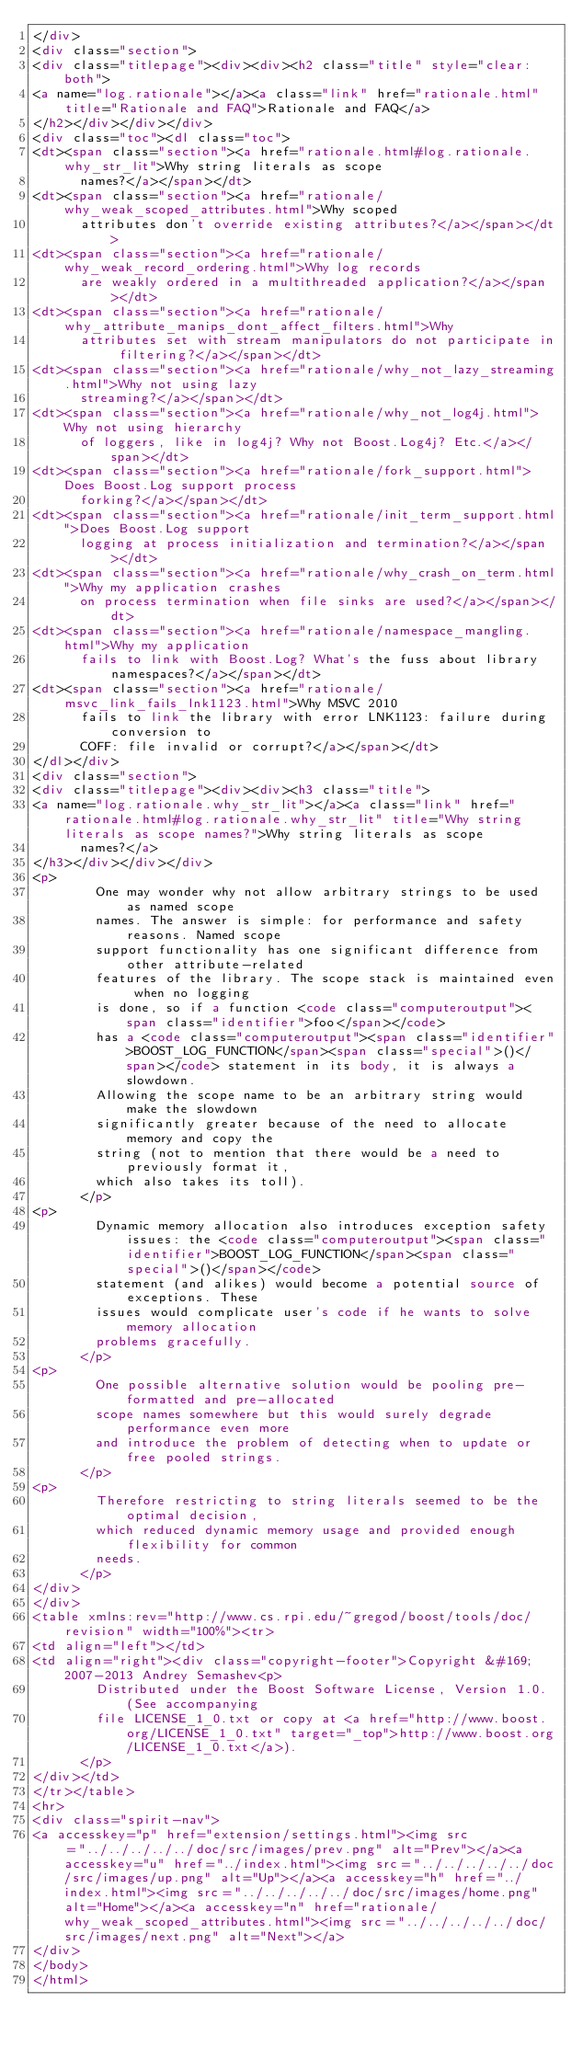Convert code to text. <code><loc_0><loc_0><loc_500><loc_500><_HTML_></div>
<div class="section">
<div class="titlepage"><div><div><h2 class="title" style="clear: both">
<a name="log.rationale"></a><a class="link" href="rationale.html" title="Rationale and FAQ">Rationale and FAQ</a>
</h2></div></div></div>
<div class="toc"><dl class="toc">
<dt><span class="section"><a href="rationale.html#log.rationale.why_str_lit">Why string literals as scope
      names?</a></span></dt>
<dt><span class="section"><a href="rationale/why_weak_scoped_attributes.html">Why scoped
      attributes don't override existing attributes?</a></span></dt>
<dt><span class="section"><a href="rationale/why_weak_record_ordering.html">Why log records
      are weakly ordered in a multithreaded application?</a></span></dt>
<dt><span class="section"><a href="rationale/why_attribute_manips_dont_affect_filters.html">Why
      attributes set with stream manipulators do not participate in filtering?</a></span></dt>
<dt><span class="section"><a href="rationale/why_not_lazy_streaming.html">Why not using lazy
      streaming?</a></span></dt>
<dt><span class="section"><a href="rationale/why_not_log4j.html">Why not using hierarchy
      of loggers, like in log4j? Why not Boost.Log4j? Etc.</a></span></dt>
<dt><span class="section"><a href="rationale/fork_support.html">Does Boost.Log support process
      forking?</a></span></dt>
<dt><span class="section"><a href="rationale/init_term_support.html">Does Boost.Log support
      logging at process initialization and termination?</a></span></dt>
<dt><span class="section"><a href="rationale/why_crash_on_term.html">Why my application crashes
      on process termination when file sinks are used?</a></span></dt>
<dt><span class="section"><a href="rationale/namespace_mangling.html">Why my application
      fails to link with Boost.Log? What's the fuss about library namespaces?</a></span></dt>
<dt><span class="section"><a href="rationale/msvc_link_fails_lnk1123.html">Why MSVC 2010
      fails to link the library with error LNK1123: failure during conversion to
      COFF: file invalid or corrupt?</a></span></dt>
</dl></div>
<div class="section">
<div class="titlepage"><div><div><h3 class="title">
<a name="log.rationale.why_str_lit"></a><a class="link" href="rationale.html#log.rationale.why_str_lit" title="Why string literals as scope names?">Why string literals as scope
      names?</a>
</h3></div></div></div>
<p>
        One may wonder why not allow arbitrary strings to be used as named scope
        names. The answer is simple: for performance and safety reasons. Named scope
        support functionality has one significant difference from other attribute-related
        features of the library. The scope stack is maintained even when no logging
        is done, so if a function <code class="computeroutput"><span class="identifier">foo</span></code>
        has a <code class="computeroutput"><span class="identifier">BOOST_LOG_FUNCTION</span><span class="special">()</span></code> statement in its body, it is always a slowdown.
        Allowing the scope name to be an arbitrary string would make the slowdown
        significantly greater because of the need to allocate memory and copy the
        string (not to mention that there would be a need to previously format it,
        which also takes its toll).
      </p>
<p>
        Dynamic memory allocation also introduces exception safety issues: the <code class="computeroutput"><span class="identifier">BOOST_LOG_FUNCTION</span><span class="special">()</span></code>
        statement (and alikes) would become a potential source of exceptions. These
        issues would complicate user's code if he wants to solve memory allocation
        problems gracefully.
      </p>
<p>
        One possible alternative solution would be pooling pre-formatted and pre-allocated
        scope names somewhere but this would surely degrade performance even more
        and introduce the problem of detecting when to update or free pooled strings.
      </p>
<p>
        Therefore restricting to string literals seemed to be the optimal decision,
        which reduced dynamic memory usage and provided enough flexibility for common
        needs.
      </p>
</div>
</div>
<table xmlns:rev="http://www.cs.rpi.edu/~gregod/boost/tools/doc/revision" width="100%"><tr>
<td align="left"></td>
<td align="right"><div class="copyright-footer">Copyright &#169; 2007-2013 Andrey Semashev<p>
        Distributed under the Boost Software License, Version 1.0. (See accompanying
        file LICENSE_1_0.txt or copy at <a href="http://www.boost.org/LICENSE_1_0.txt" target="_top">http://www.boost.org/LICENSE_1_0.txt</a>).
      </p>
</div></td>
</tr></table>
<hr>
<div class="spirit-nav">
<a accesskey="p" href="extension/settings.html"><img src="../../../../../doc/src/images/prev.png" alt="Prev"></a><a accesskey="u" href="../index.html"><img src="../../../../../doc/src/images/up.png" alt="Up"></a><a accesskey="h" href="../index.html"><img src="../../../../../doc/src/images/home.png" alt="Home"></a><a accesskey="n" href="rationale/why_weak_scoped_attributes.html"><img src="../../../../../doc/src/images/next.png" alt="Next"></a>
</div>
</body>
</html>
</code> 